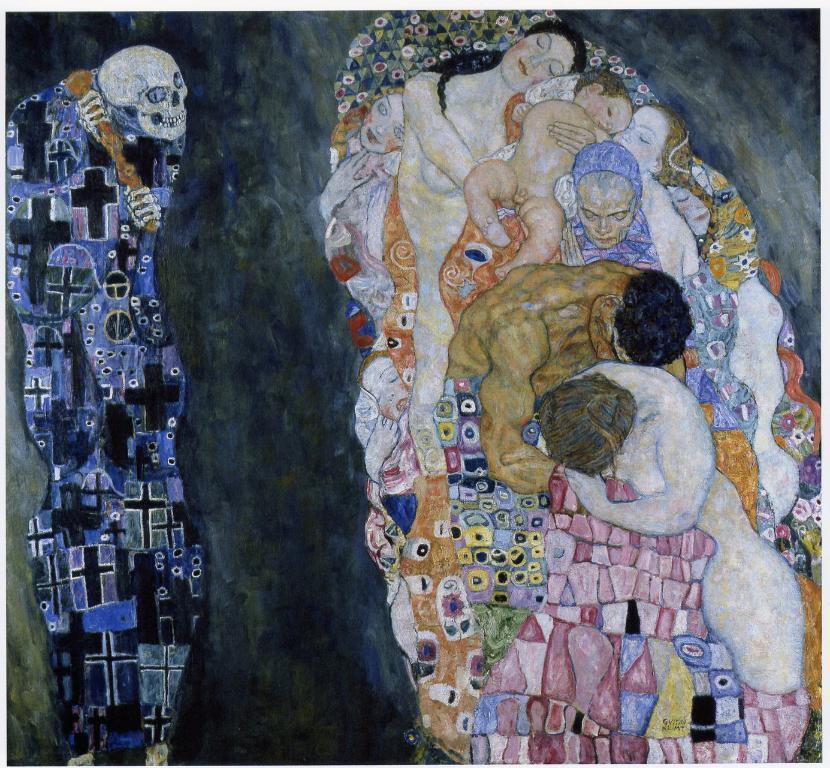Could you give a brief overview of what you see in this image? In this picture we can see the painted poster with women, small baby and man lying together in the cloth. Beside there is a skeleton. 